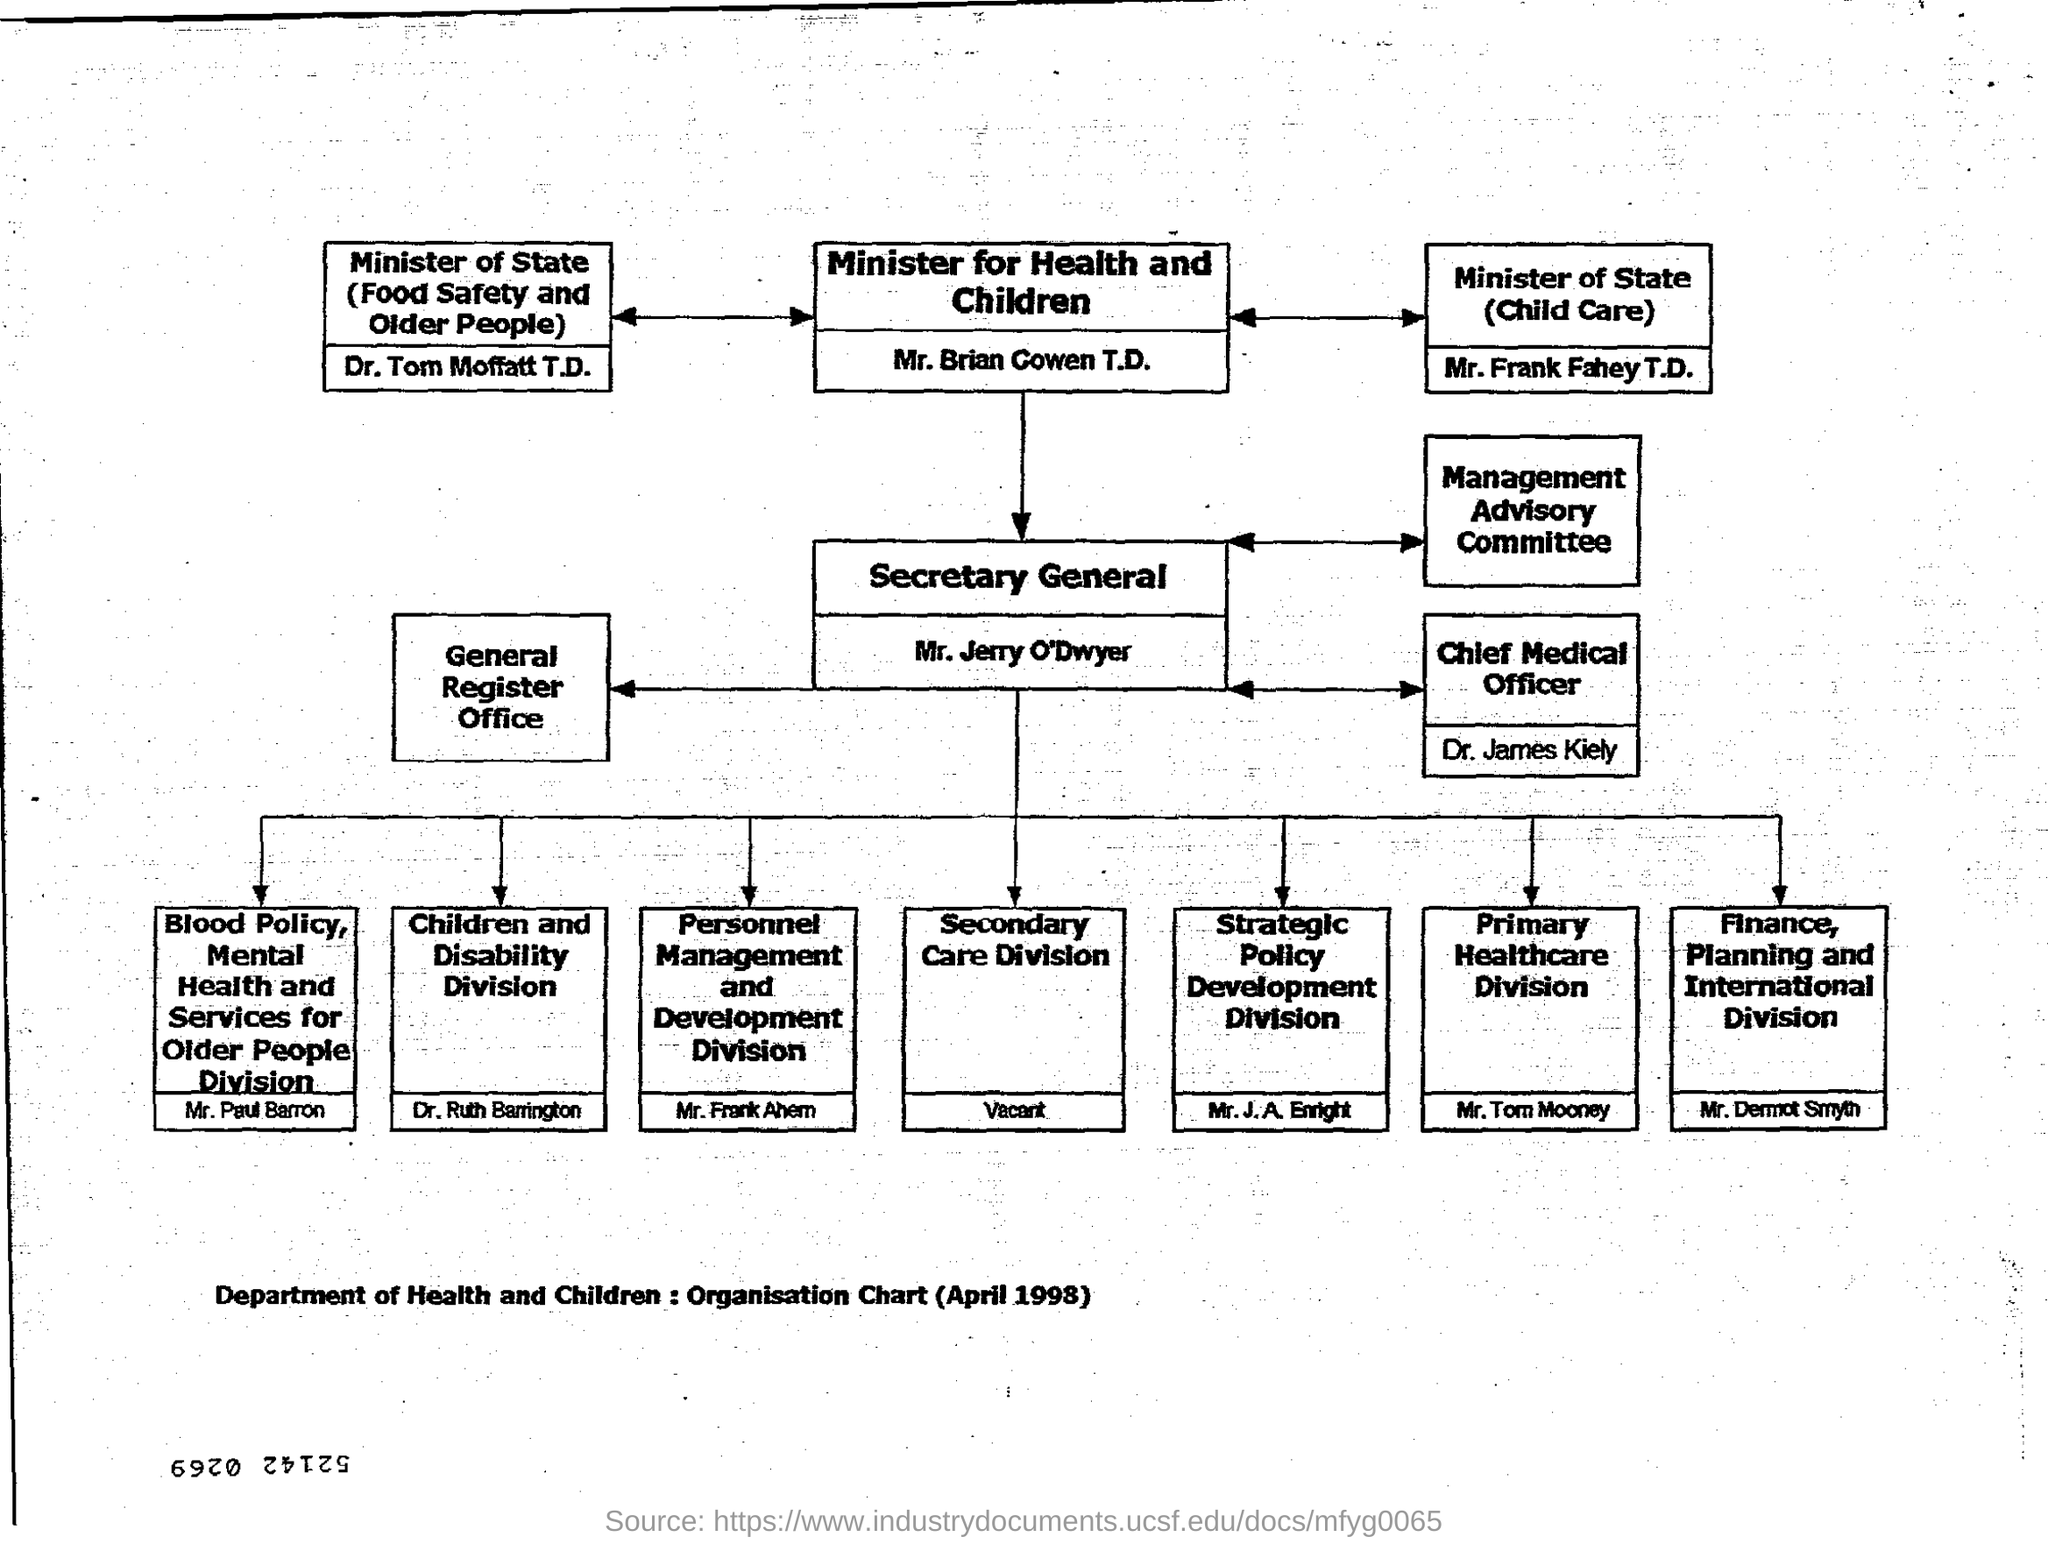What is the name of the chart?
Offer a terse response. Department of Health and Children : Organisation Chart (April 1998). Who is the Minister for Health and Children?
Offer a terse response. Mr. Brian Cowen T.D. Who is the Secretary General?
Provide a short and direct response. Mr. Jerry O'Dwyer. Who is the Chief Medical Officer?
Give a very brief answer. Dr. James Kiely. Which division is vacant?
Ensure brevity in your answer.  Secondary Care Division. Which division is taken care of by Dr. Ruth Barrington?
Your answer should be very brief. Children and Disability Division. 